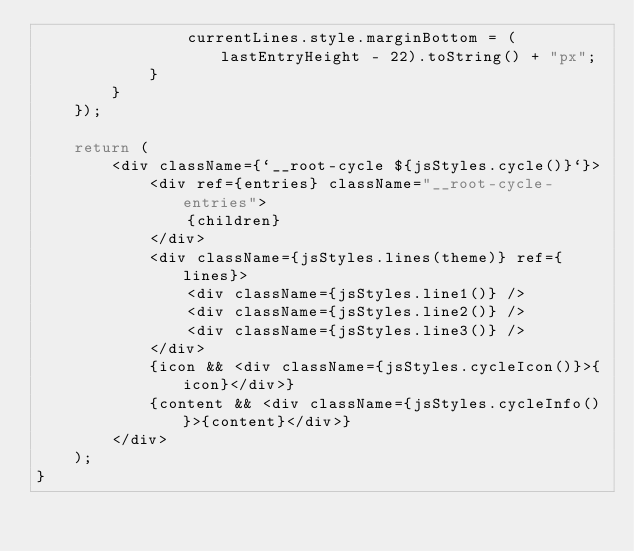Convert code to text. <code><loc_0><loc_0><loc_500><loc_500><_TypeScript_>                currentLines.style.marginBottom = (lastEntryHeight - 22).toString() + "px";
            }
        }
    });

    return (
        <div className={`__root-cycle ${jsStyles.cycle()}`}>
            <div ref={entries} className="__root-cycle-entries">
                {children}
            </div>
            <div className={jsStyles.lines(theme)} ref={lines}>
                <div className={jsStyles.line1()} />
                <div className={jsStyles.line2()} />
                <div className={jsStyles.line3()} />
            </div>
            {icon && <div className={jsStyles.cycleIcon()}>{icon}</div>}
            {content && <div className={jsStyles.cycleInfo()}>{content}</div>}
        </div>
    );
}
</code> 